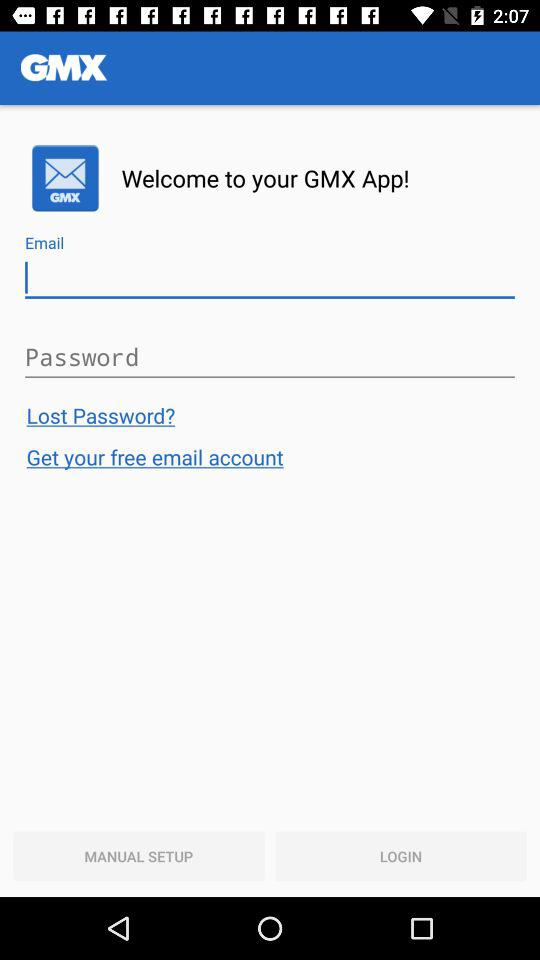What is the app name? The app name is "GMX". 